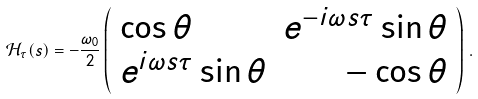Convert formula to latex. <formula><loc_0><loc_0><loc_500><loc_500>\mathcal { H } _ { \tau } ( s ) = - \frac { \omega _ { 0 } } { 2 } \left ( \begin{array} { l r } \cos \theta & e ^ { - i \omega s \tau } \sin \theta \\ e ^ { i \omega s \tau } \sin \theta & - \cos \theta \end{array} \right ) \, .</formula> 